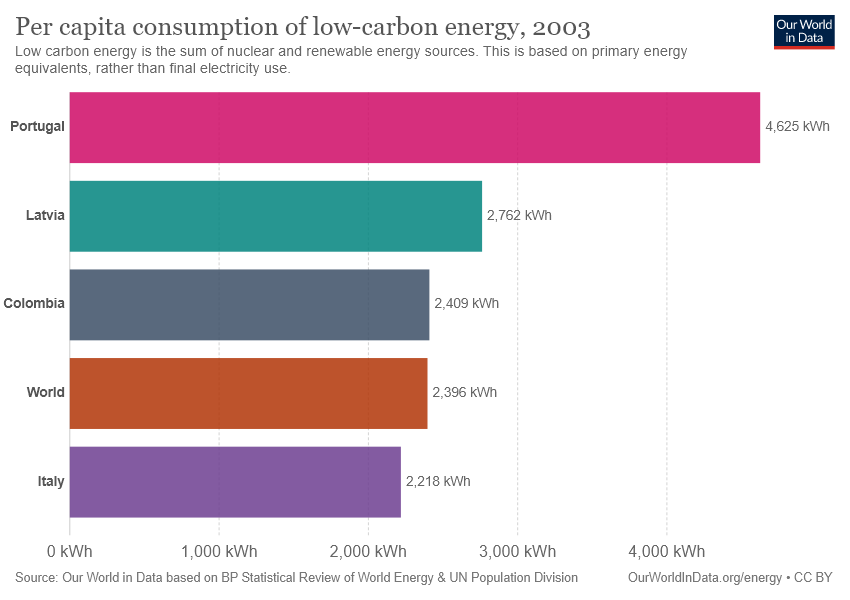Draw attention to some important aspects in this diagram. The energy consumption of Portugal is different from that of Italy. The country represented by the color violet is Italy. 